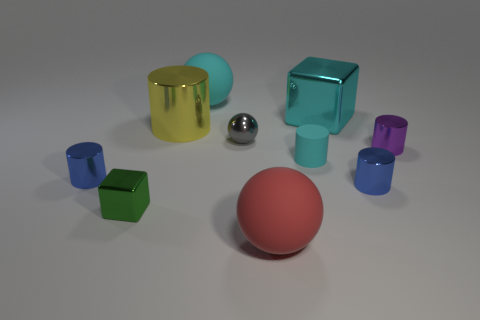Subtract all cyan cylinders. How many cylinders are left? 4 Subtract all large metallic cylinders. How many cylinders are left? 4 Subtract all green cylinders. Subtract all purple spheres. How many cylinders are left? 5 Subtract all spheres. How many objects are left? 7 Subtract 0 red cylinders. How many objects are left? 10 Subtract all cyan matte blocks. Subtract all blue metal objects. How many objects are left? 8 Add 8 large red rubber balls. How many large red rubber balls are left? 9 Add 7 brown matte objects. How many brown matte objects exist? 7 